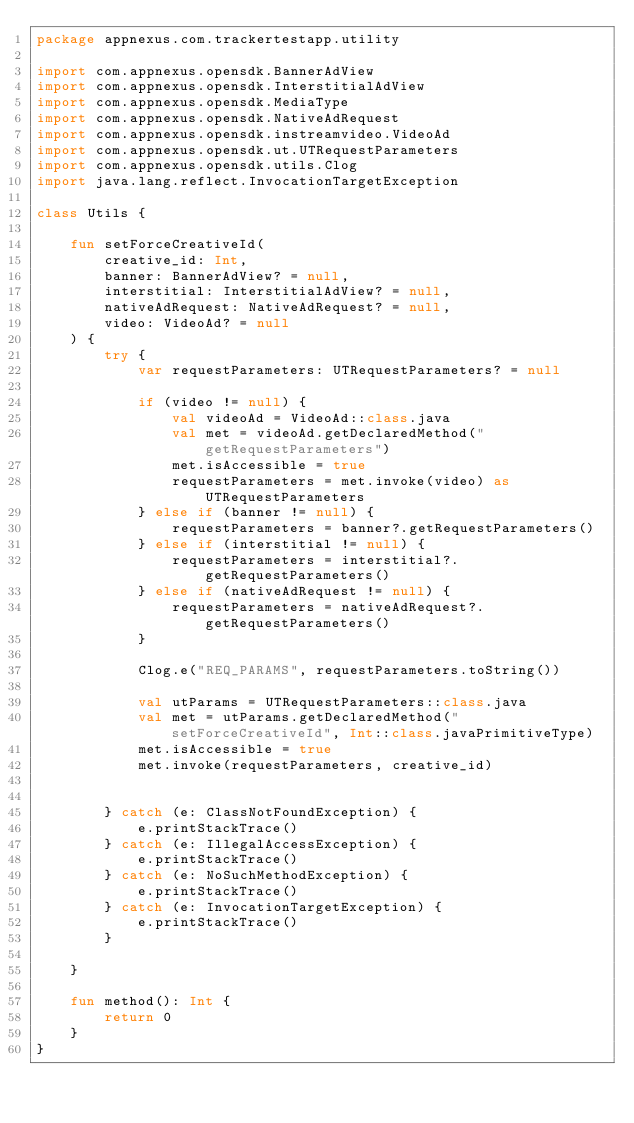<code> <loc_0><loc_0><loc_500><loc_500><_Kotlin_>package appnexus.com.trackertestapp.utility

import com.appnexus.opensdk.BannerAdView
import com.appnexus.opensdk.InterstitialAdView
import com.appnexus.opensdk.MediaType
import com.appnexus.opensdk.NativeAdRequest
import com.appnexus.opensdk.instreamvideo.VideoAd
import com.appnexus.opensdk.ut.UTRequestParameters
import com.appnexus.opensdk.utils.Clog
import java.lang.reflect.InvocationTargetException

class Utils {

    fun setForceCreativeId(
        creative_id: Int,
        banner: BannerAdView? = null,
        interstitial: InterstitialAdView? = null,
        nativeAdRequest: NativeAdRequest? = null,
        video: VideoAd? = null
    ) {
        try {
            var requestParameters: UTRequestParameters? = null

            if (video != null) {
                val videoAd = VideoAd::class.java
                val met = videoAd.getDeclaredMethod("getRequestParameters")
                met.isAccessible = true
                requestParameters = met.invoke(video) as UTRequestParameters
            } else if (banner != null) {
                requestParameters = banner?.getRequestParameters()
            } else if (interstitial != null) {
                requestParameters = interstitial?.getRequestParameters()
            } else if (nativeAdRequest != null) {
                requestParameters = nativeAdRequest?.getRequestParameters()
            }

            Clog.e("REQ_PARAMS", requestParameters.toString())

            val utParams = UTRequestParameters::class.java
            val met = utParams.getDeclaredMethod("setForceCreativeId", Int::class.javaPrimitiveType)
            met.isAccessible = true
            met.invoke(requestParameters, creative_id)


        } catch (e: ClassNotFoundException) {
            e.printStackTrace()
        } catch (e: IllegalAccessException) {
            e.printStackTrace()
        } catch (e: NoSuchMethodException) {
            e.printStackTrace()
        } catch (e: InvocationTargetException) {
            e.printStackTrace()
        }

    }

    fun method(): Int {
        return 0
    }
}</code> 